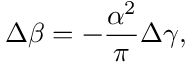<formula> <loc_0><loc_0><loc_500><loc_500>\Delta \beta = - \frac { \alpha ^ { 2 } } { \pi } \Delta \gamma ,</formula> 